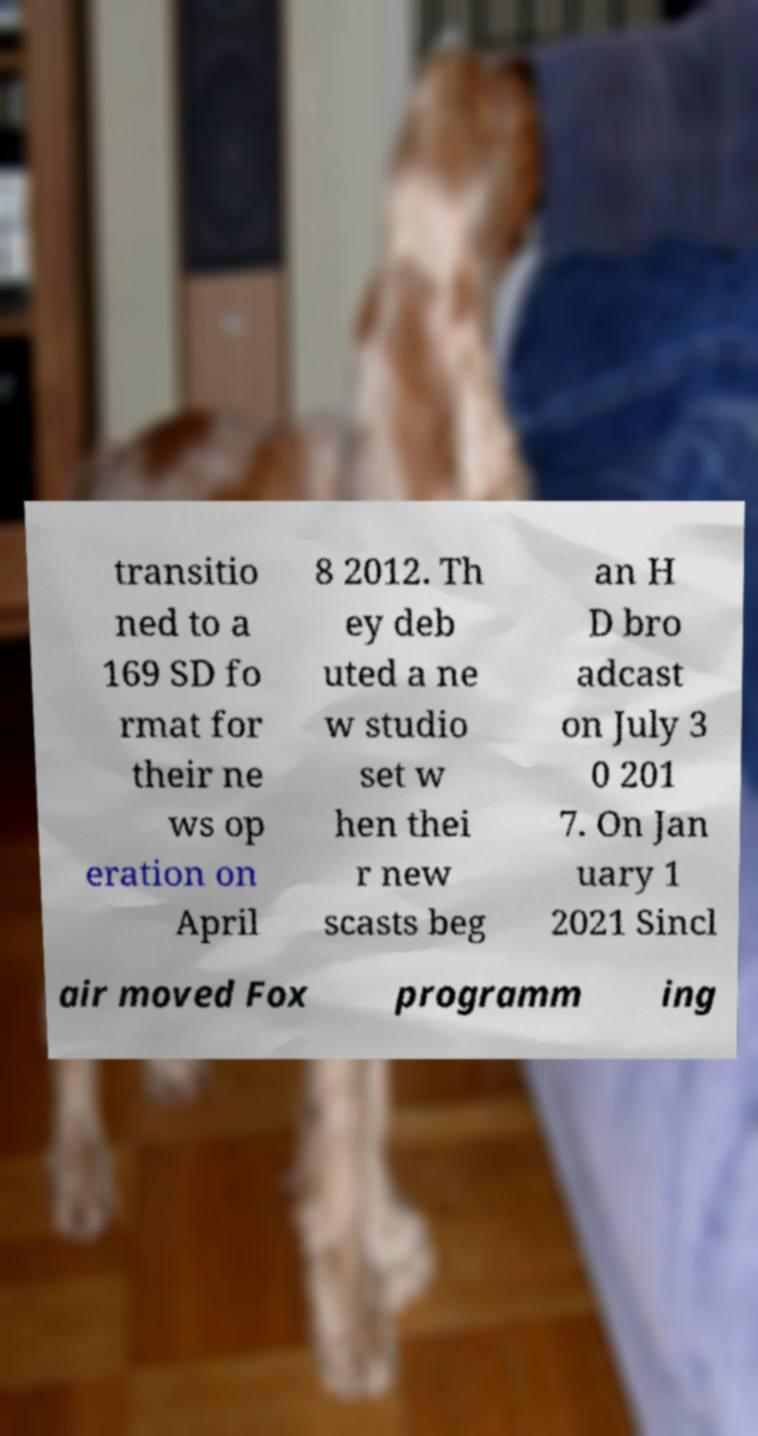For documentation purposes, I need the text within this image transcribed. Could you provide that? transitio ned to a 169 SD fo rmat for their ne ws op eration on April 8 2012. Th ey deb uted a ne w studio set w hen thei r new scasts beg an H D bro adcast on July 3 0 201 7. On Jan uary 1 2021 Sincl air moved Fox programm ing 